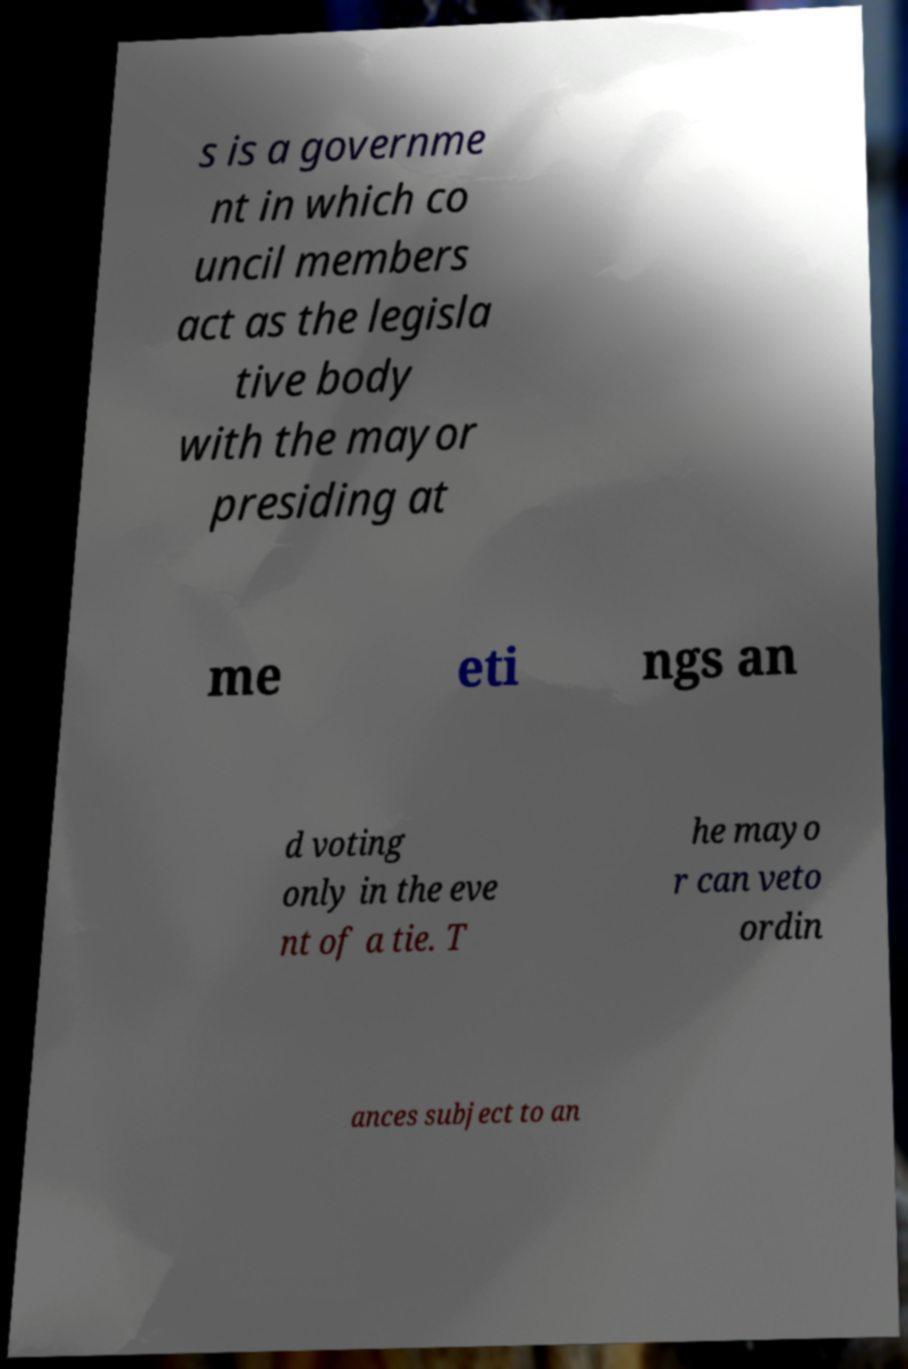Could you assist in decoding the text presented in this image and type it out clearly? s is a governme nt in which co uncil members act as the legisla tive body with the mayor presiding at me eti ngs an d voting only in the eve nt of a tie. T he mayo r can veto ordin ances subject to an 